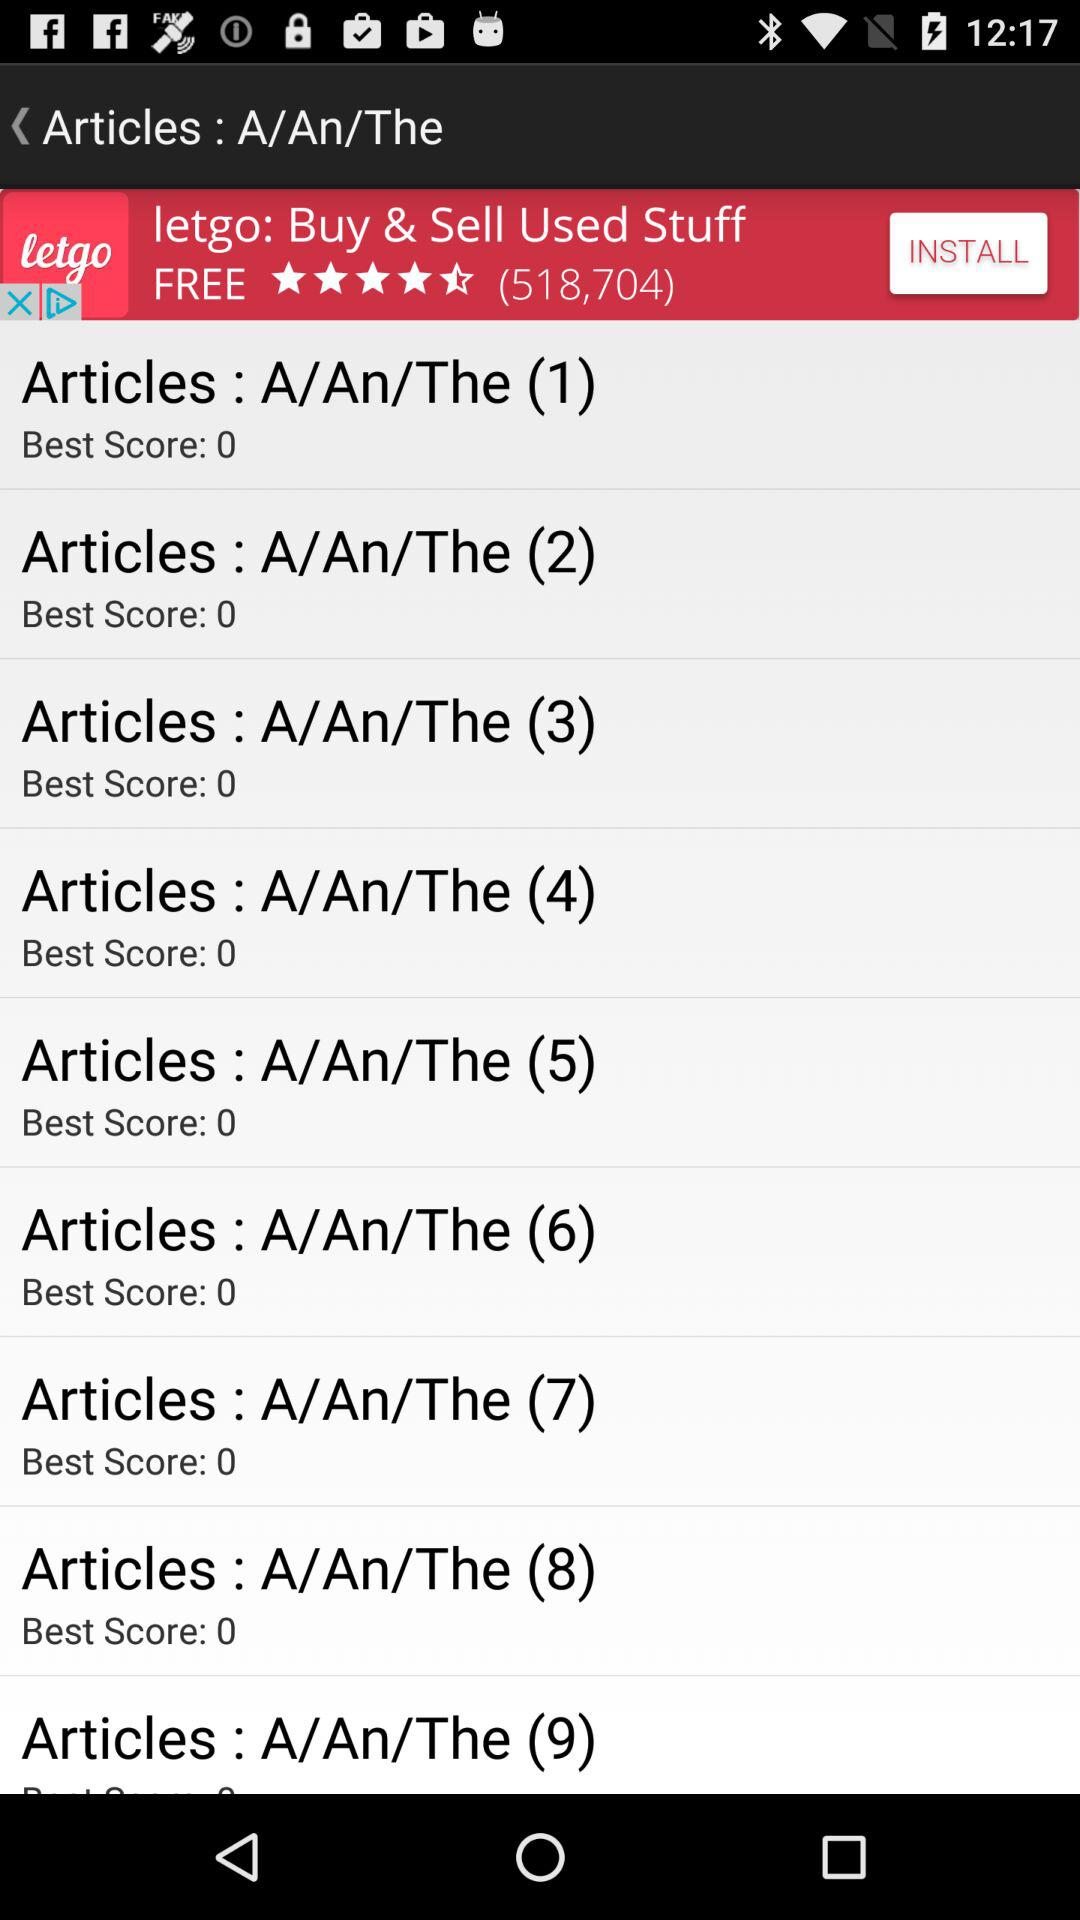What is the best score of "Articles : A/An/The (5)"? The best score of "Articles : A/An/The (5)" is 0. 